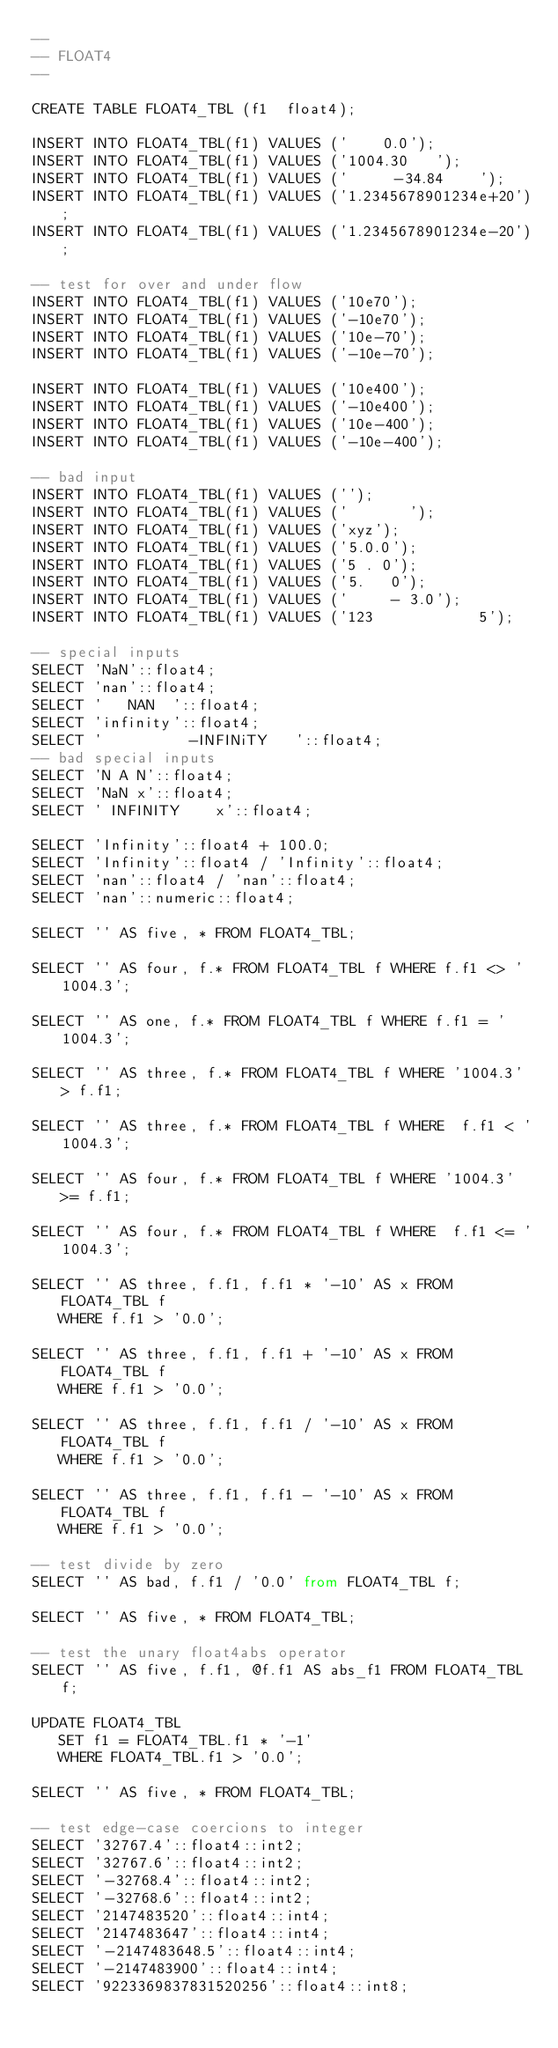<code> <loc_0><loc_0><loc_500><loc_500><_SQL_>--
-- FLOAT4
--

CREATE TABLE FLOAT4_TBL (f1  float4);

INSERT INTO FLOAT4_TBL(f1) VALUES ('    0.0');
INSERT INTO FLOAT4_TBL(f1) VALUES ('1004.30   ');
INSERT INTO FLOAT4_TBL(f1) VALUES ('     -34.84    ');
INSERT INTO FLOAT4_TBL(f1) VALUES ('1.2345678901234e+20');
INSERT INTO FLOAT4_TBL(f1) VALUES ('1.2345678901234e-20');

-- test for over and under flow
INSERT INTO FLOAT4_TBL(f1) VALUES ('10e70');
INSERT INTO FLOAT4_TBL(f1) VALUES ('-10e70');
INSERT INTO FLOAT4_TBL(f1) VALUES ('10e-70');
INSERT INTO FLOAT4_TBL(f1) VALUES ('-10e-70');

INSERT INTO FLOAT4_TBL(f1) VALUES ('10e400');
INSERT INTO FLOAT4_TBL(f1) VALUES ('-10e400');
INSERT INTO FLOAT4_TBL(f1) VALUES ('10e-400');
INSERT INTO FLOAT4_TBL(f1) VALUES ('-10e-400');

-- bad input
INSERT INTO FLOAT4_TBL(f1) VALUES ('');
INSERT INTO FLOAT4_TBL(f1) VALUES ('       ');
INSERT INTO FLOAT4_TBL(f1) VALUES ('xyz');
INSERT INTO FLOAT4_TBL(f1) VALUES ('5.0.0');
INSERT INTO FLOAT4_TBL(f1) VALUES ('5 . 0');
INSERT INTO FLOAT4_TBL(f1) VALUES ('5.   0');
INSERT INTO FLOAT4_TBL(f1) VALUES ('     - 3.0');
INSERT INTO FLOAT4_TBL(f1) VALUES ('123            5');

-- special inputs
SELECT 'NaN'::float4;
SELECT 'nan'::float4;
SELECT '   NAN  '::float4;
SELECT 'infinity'::float4;
SELECT '          -INFINiTY   '::float4;
-- bad special inputs
SELECT 'N A N'::float4;
SELECT 'NaN x'::float4;
SELECT ' INFINITY    x'::float4;

SELECT 'Infinity'::float4 + 100.0;
SELECT 'Infinity'::float4 / 'Infinity'::float4;
SELECT 'nan'::float4 / 'nan'::float4;
SELECT 'nan'::numeric::float4;

SELECT '' AS five, * FROM FLOAT4_TBL;

SELECT '' AS four, f.* FROM FLOAT4_TBL f WHERE f.f1 <> '1004.3';

SELECT '' AS one, f.* FROM FLOAT4_TBL f WHERE f.f1 = '1004.3';

SELECT '' AS three, f.* FROM FLOAT4_TBL f WHERE '1004.3' > f.f1;

SELECT '' AS three, f.* FROM FLOAT4_TBL f WHERE  f.f1 < '1004.3';

SELECT '' AS four, f.* FROM FLOAT4_TBL f WHERE '1004.3' >= f.f1;

SELECT '' AS four, f.* FROM FLOAT4_TBL f WHERE  f.f1 <= '1004.3';

SELECT '' AS three, f.f1, f.f1 * '-10' AS x FROM FLOAT4_TBL f
   WHERE f.f1 > '0.0';

SELECT '' AS three, f.f1, f.f1 + '-10' AS x FROM FLOAT4_TBL f
   WHERE f.f1 > '0.0';

SELECT '' AS three, f.f1, f.f1 / '-10' AS x FROM FLOAT4_TBL f
   WHERE f.f1 > '0.0';

SELECT '' AS three, f.f1, f.f1 - '-10' AS x FROM FLOAT4_TBL f
   WHERE f.f1 > '0.0';

-- test divide by zero
SELECT '' AS bad, f.f1 / '0.0' from FLOAT4_TBL f;

SELECT '' AS five, * FROM FLOAT4_TBL;

-- test the unary float4abs operator
SELECT '' AS five, f.f1, @f.f1 AS abs_f1 FROM FLOAT4_TBL f;

UPDATE FLOAT4_TBL
   SET f1 = FLOAT4_TBL.f1 * '-1'
   WHERE FLOAT4_TBL.f1 > '0.0';

SELECT '' AS five, * FROM FLOAT4_TBL;

-- test edge-case coercions to integer
SELECT '32767.4'::float4::int2;
SELECT '32767.6'::float4::int2;
SELECT '-32768.4'::float4::int2;
SELECT '-32768.6'::float4::int2;
SELECT '2147483520'::float4::int4;
SELECT '2147483647'::float4::int4;
SELECT '-2147483648.5'::float4::int4;
SELECT '-2147483900'::float4::int4;
SELECT '9223369837831520256'::float4::int8;</code> 